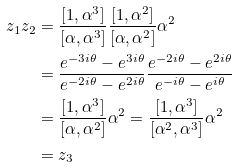Convert formula to latex. <formula><loc_0><loc_0><loc_500><loc_500>z _ { 1 } z _ { 2 } & = \frac { [ 1 , \alpha ^ { 3 } ] } { [ \alpha , \alpha ^ { 3 } ] } \frac { [ 1 , \alpha ^ { 2 } ] } { [ \alpha , \alpha ^ { 2 } ] } \alpha ^ { 2 } \\ & = \frac { e ^ { - 3 i \theta } - e ^ { 3 i \theta } } { e ^ { - 2 i \theta } - e ^ { 2 i \theta } } \frac { e ^ { - 2 i \theta } - e ^ { 2 i \theta } } { e ^ { - i \theta } - e ^ { i \theta } } \\ & = \frac { [ 1 , \alpha ^ { 3 } ] } { [ \alpha , \alpha ^ { 2 } ] } \alpha ^ { 2 } = \frac { [ 1 , \alpha ^ { 3 } ] } { [ \alpha ^ { 2 } , \alpha ^ { 3 } ] } \alpha ^ { 2 } \\ & = z _ { 3 }</formula> 